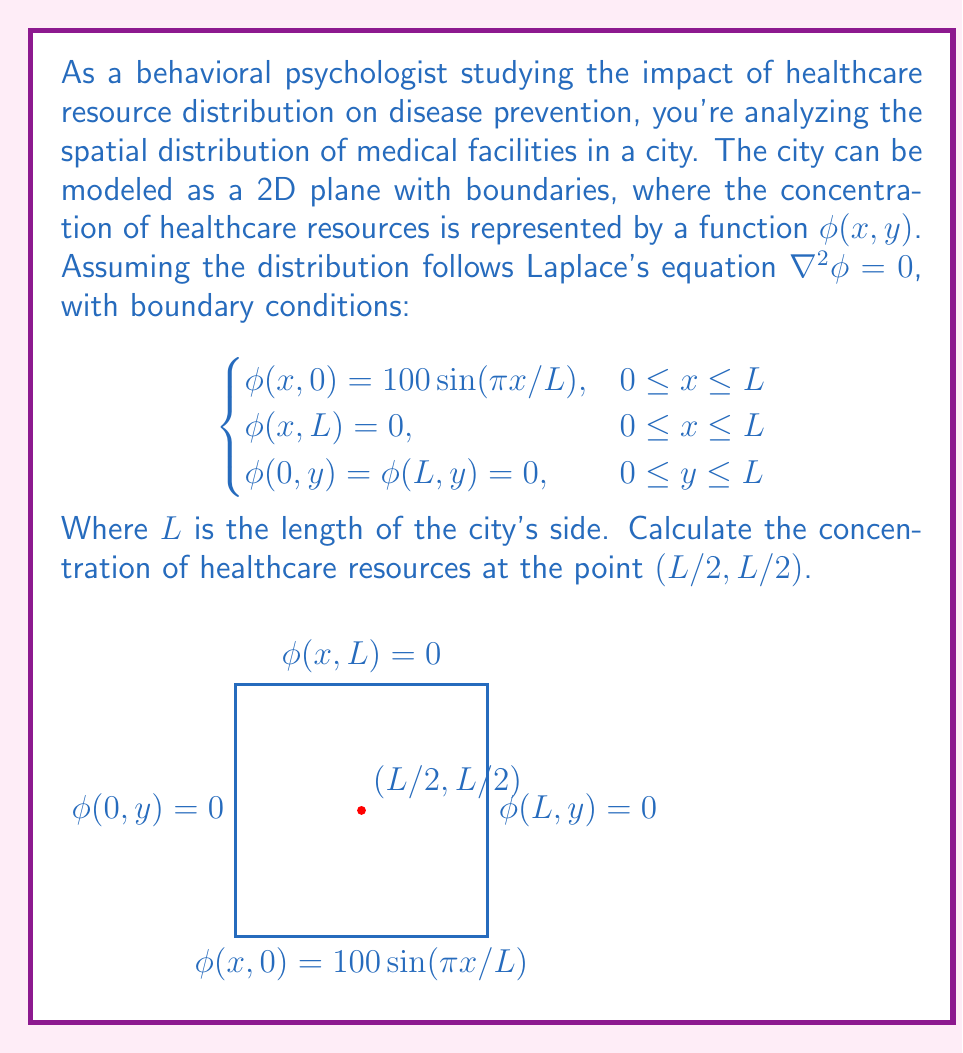Show me your answer to this math problem. To solve this problem, we'll follow these steps:

1) The general solution to Laplace's equation in 2D with the given boundary conditions is:

   $$\phi(x,y) = \sum_{n=1}^{\infty} A_n \sin(\frac{n\pi x}{L}) \sinh(\frac{n\pi y}{L})$$

2) The boundary condition at $y=0$ gives:

   $$100 \sin(\frac{\pi x}{L}) = \sum_{n=1}^{\infty} A_n \sin(\frac{n\pi x}{L}) \sinh(0)$$

   This implies that $A_1 = 100$ and $A_n = 0$ for $n > 1$.

3) Therefore, the solution simplifies to:

   $$\phi(x,y) = 100 \sin(\frac{\pi x}{L}) \sinh(\frac{\pi y}{L})$$

4) The boundary condition at $y=L$ is automatically satisfied because $\sinh(\pi) = 0$.

5) To find the concentration at $(L/2, L/2)$, we substitute these values:

   $$\phi(\frac{L}{2}, \frac{L}{2}) = 100 \sin(\frac{\pi}{2}) \sinh(\frac{\pi}{2})$$

6) We know that $\sin(\frac{\pi}{2}) = 1$ and $\sinh(\frac{\pi}{2}) \approx 2.3012$.

7) Therefore:

   $$\phi(\frac{L}{2}, \frac{L}{2}) = 100 \cdot 1 \cdot 2.3012 = 230.12$$

Thus, the concentration of healthcare resources at the center of the city $(L/2, L/2)$ is approximately 230.12 units.
Answer: 230.12 units 